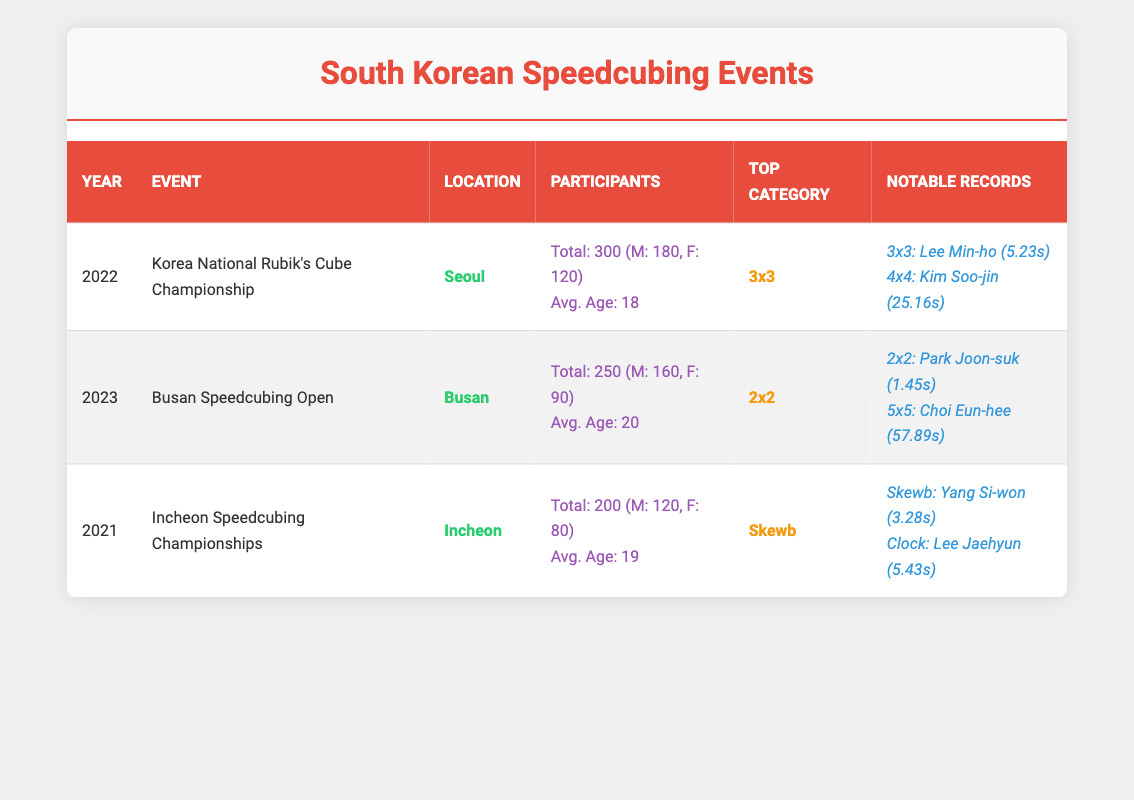What was the total number of participants in the 2022 Korea National Rubik's Cube Championship? Referring to the table, the total number of participants for the 2022 event is listed as 300.
Answer: 300 Which event had the highest number of female participants? By comparing the female participant counts across the events: 2022 has 120, 2023 has 90, and 2021 has 80. The highest is 120 in 2022.
Answer: 2022 What is the average age of participants in the Busan Speedcubing Open? According to the table, the average age for the 2023 Busan Speedcubing Open is stated as 20.
Answer: 20 Did the number of total participants increase or decrease from 2021 to 2022? In 2021, there were 200 participants; in 2022, there were 300. Thus, the participation increased from 200 to 300.
Answer: Increased Which event had a top category of 3x3? The Korea National Rubik's Cube Championship in 2022 had the top category listed as 3x3.
Answer: 2022 What is the combined total of male participants from all events listed? The male participants are: 180 (2022) + 160 (2023) + 120 (2021) = 460.
Answer: 460 Is it true that the average age of participants in the Incheon Speedcubing Championships was younger than 20? The average age in the Incheon Speedcubing Championships was 19, which is younger than 20.
Answer: True What record does Lee Min-ho hold and what is the time? Lee Min-ho holds the record for 3x3 with a time of 5.23 seconds as listed in the notable records.
Answer: 5.23 seconds (3x3) How many more male participants were there in 2022 compared to 2021? There were 180 male participants in 2022 and 120 in 2021, so the difference is 180 - 120 = 60 more male participants.
Answer: 60 Which event had the lowest total number of participants? Comparing total participants from each event: 200 (2021), 300 (2022), and 250 (2023); the lowest is 200 in Incheon Speedcubing Championships.
Answer: Incheon Speedcubing Championships 